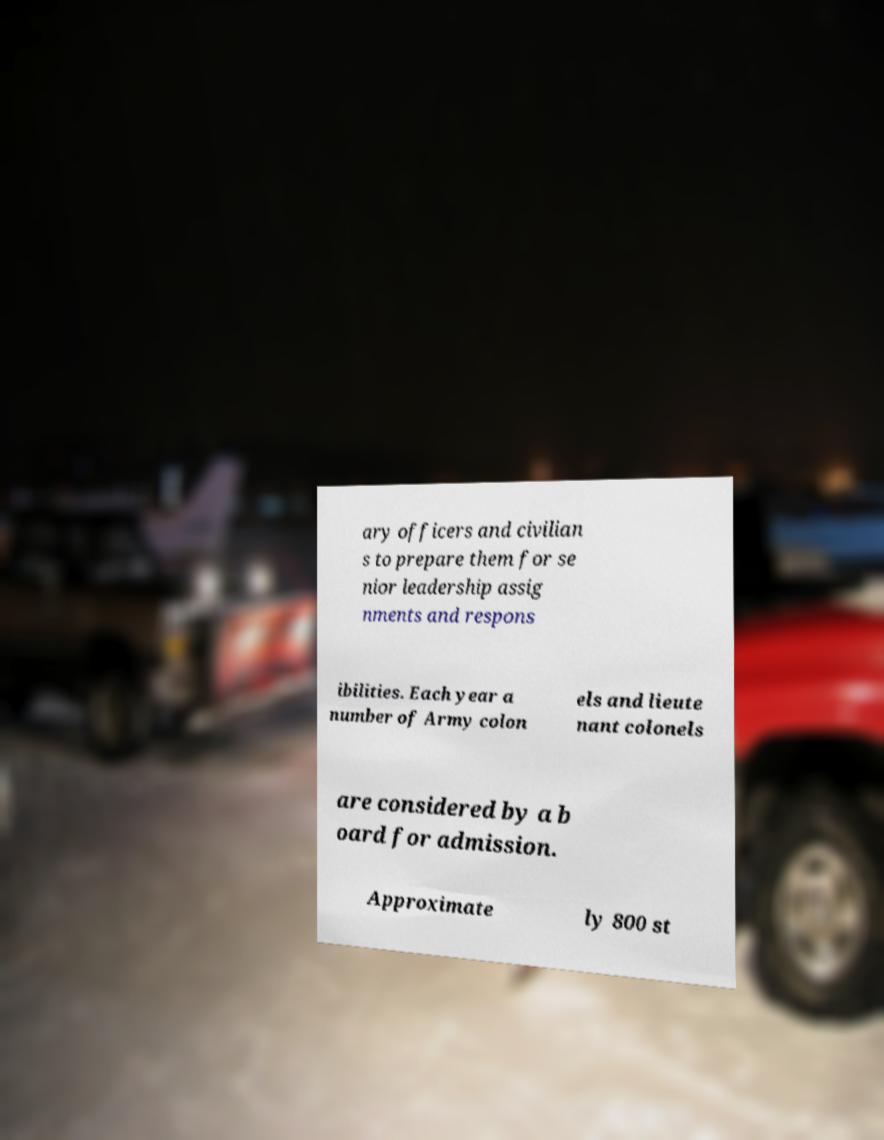For documentation purposes, I need the text within this image transcribed. Could you provide that? ary officers and civilian s to prepare them for se nior leadership assig nments and respons ibilities. Each year a number of Army colon els and lieute nant colonels are considered by a b oard for admission. Approximate ly 800 st 